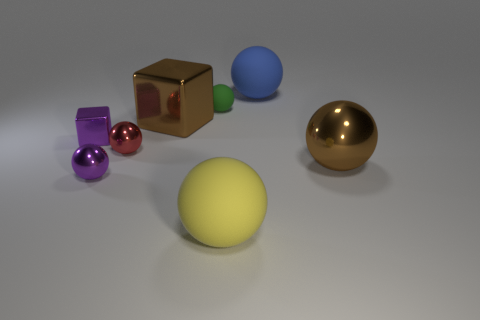Subtract all large blue rubber spheres. How many spheres are left? 5 Subtract all spheres. How many objects are left? 2 Add 1 blue things. How many blue things are left? 2 Add 7 big blue rubber things. How many big blue rubber things exist? 8 Add 1 small red shiny spheres. How many objects exist? 9 Subtract all red balls. How many balls are left? 5 Subtract 0 gray cylinders. How many objects are left? 8 Subtract 3 spheres. How many spheres are left? 3 Subtract all cyan blocks. Subtract all brown spheres. How many blocks are left? 2 Subtract all green cylinders. How many purple balls are left? 1 